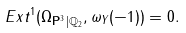Convert formula to latex. <formula><loc_0><loc_0><loc_500><loc_500>E x t ^ { 1 } ( { \Omega _ { \mathbf P ^ { 3 } } } _ { | \mathbb { Q } _ { 2 } } , \omega _ { Y } ( - 1 ) ) = 0 .</formula> 